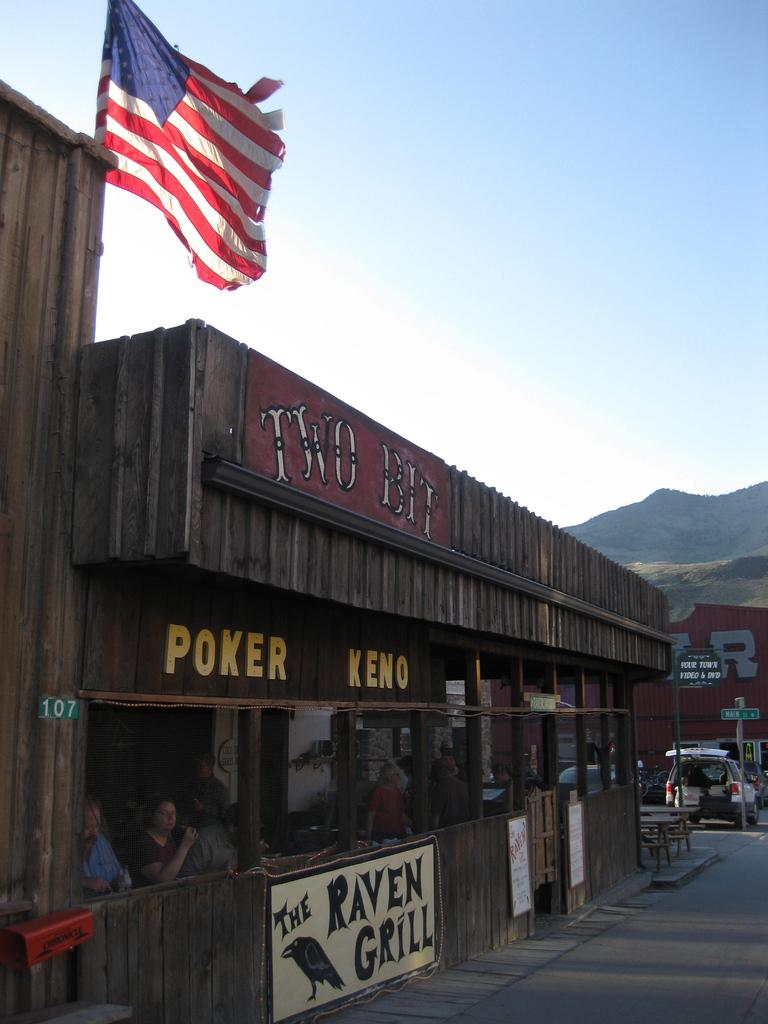What type of establishment is shown in the image? There is a restaurant in the image. What can be seen on the left side of the image? There is a national flag on the left side of the image. What is visible on the right side of the image? There is a car on the road on the right side of the image. What can be seen in the background of the image? Hills and the sky are visible in the background of the image. What type of honey is being served at the restaurant in the image? There is no honey being served in the image, as the focus is on the restaurant, national flag, car, hills, and sky. 